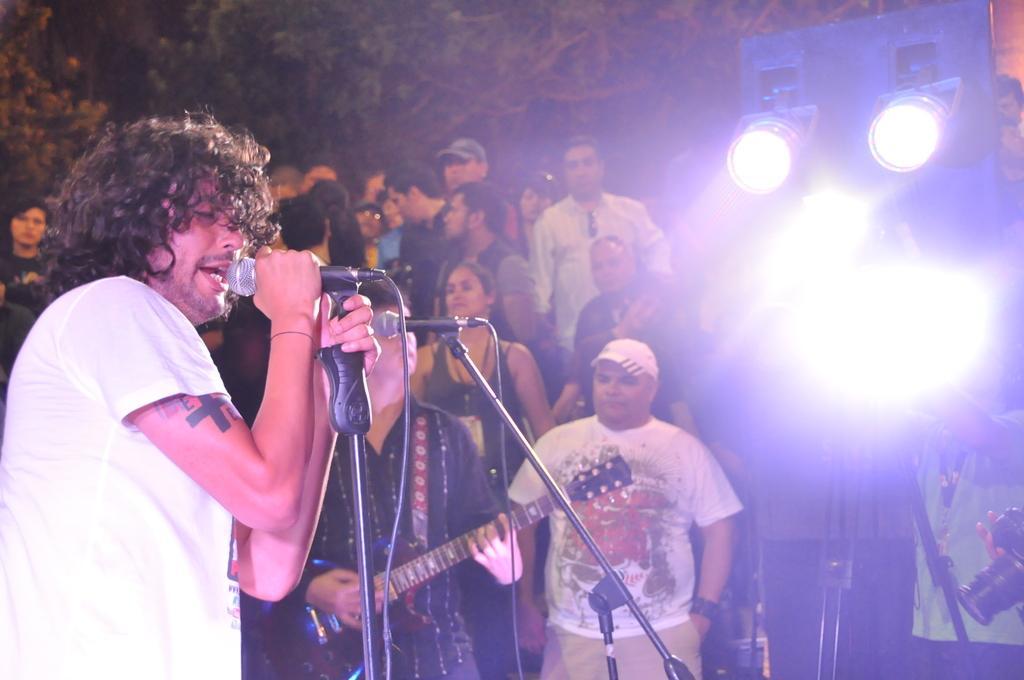How would you summarize this image in a sentence or two? In this image the person playing the guitar and singing other persons are watching and in front of the person there are some lights behind the persons some trees are there and the background is little dark. 